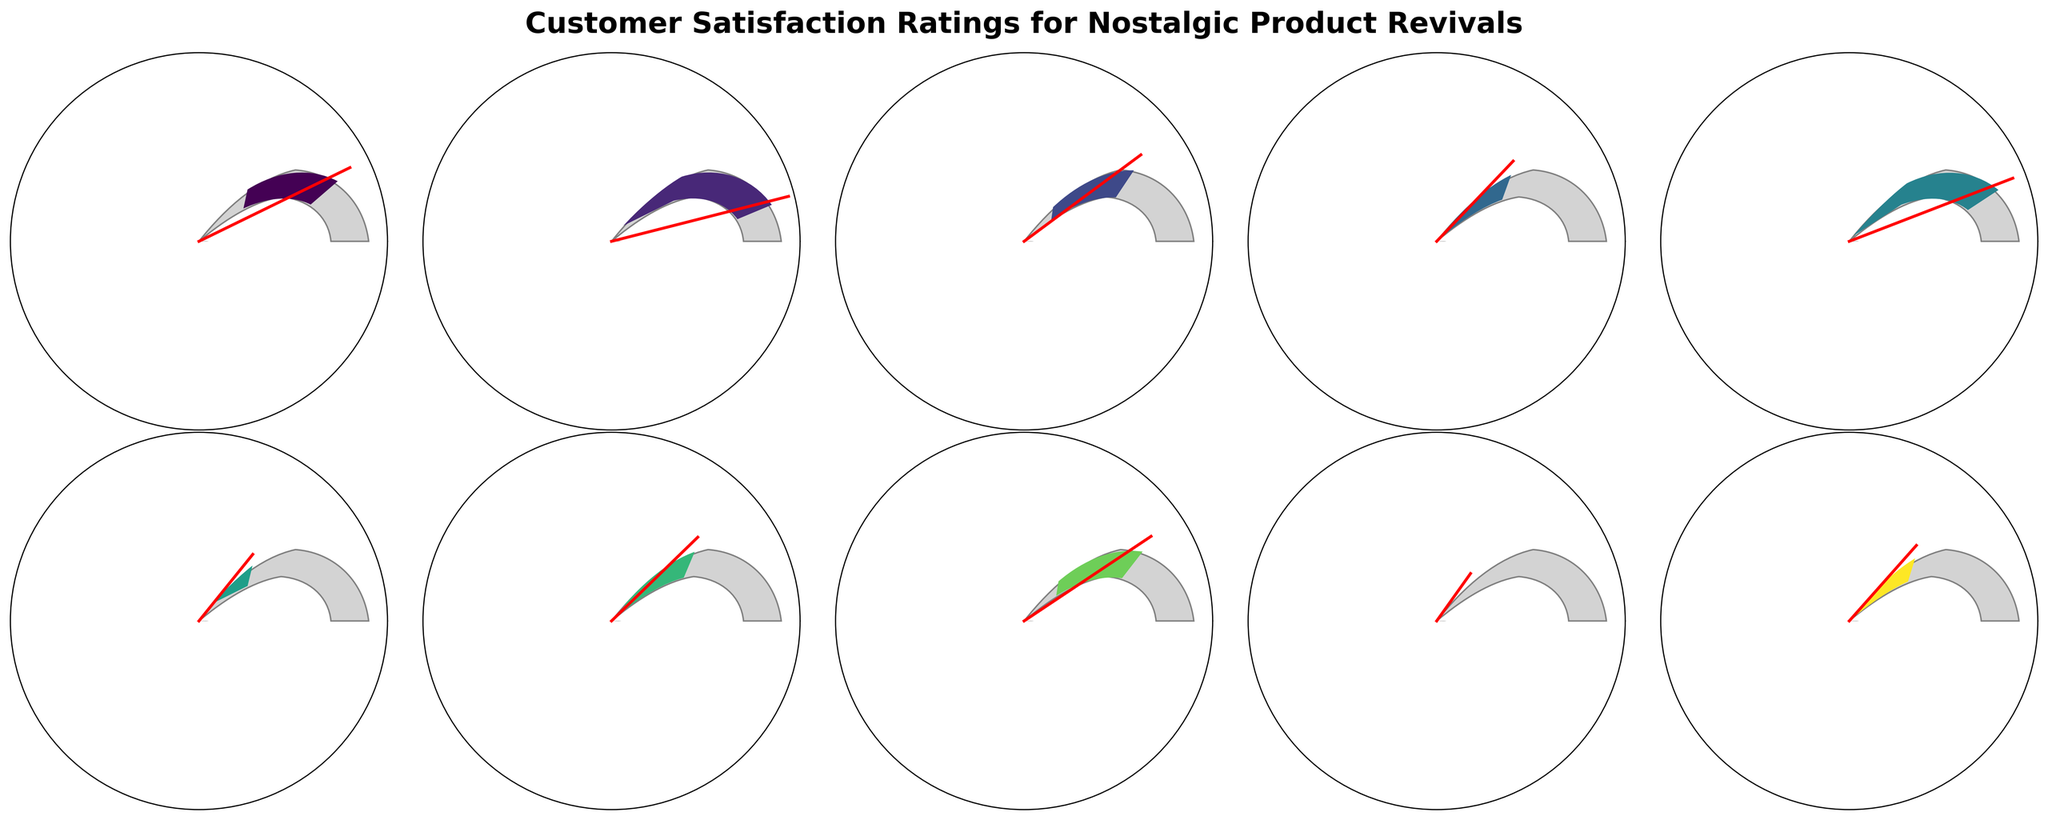Which product has the highest customer satisfaction rating? By looking at the gauge charts, the product with the furthest needle along the gauge toward 100% has the highest rating.
Answer: Nintendo NES Classic Edition What is the customer satisfaction rating of the Crystal Pepsi? Locate the gauge chart labeled "Crystal Pepsi" and read the percentage indicated by the needle.
Answer: 60% Out of the listed products, which one has the lowest customer satisfaction rating? Find the gauge chart with the needle closest to 0%.
Answer: Crystal Pepsi How many products have a satisfaction rating of 80% or higher? Count the number of gauge charts where the needle indicates a satisfaction rating of 80 or above.
Answer: 5 What is the average satisfaction rating of all the products? Add up all the satisfaction ratings and divide by the number of products: (85 + 92 + 78 + 70 + 88 + 65 + 72 + 80 + 60 + 68) / 10 = 75.8
Answer: 75.8 What is the difference in customer satisfaction ratings between the highest and lowest rated products? Subtract the lowest rating from the highest rating: 92 (highest) - 60 (lowest) = 32
Answer: 32 Which product has a higher rating: Vinyl Records or Juicy Couture Tracksuits? Compare the satisfaction ratings indicated on the gauges of "Vinyl Records" (88%) and "Juicy Couture Tracksuits" (72%).
Answer: Vinyl Records Does Tamagotchi have a higher satisfaction rating than Motorola Razr (2020 version)? Compare the gauges of "Tamagotchi" (70%) and "Motorola Razr (2020 version)" (68%).
Answer: Yes How does the satisfaction rating of Polaroid OneStep 2 compare to Furbies? Compare the satisfaction ratings on the gauges of "Polaroid OneStep 2" (78%) and "Furbies" (65%).
Answer: Polaroid OneStep 2 has a higher rating 